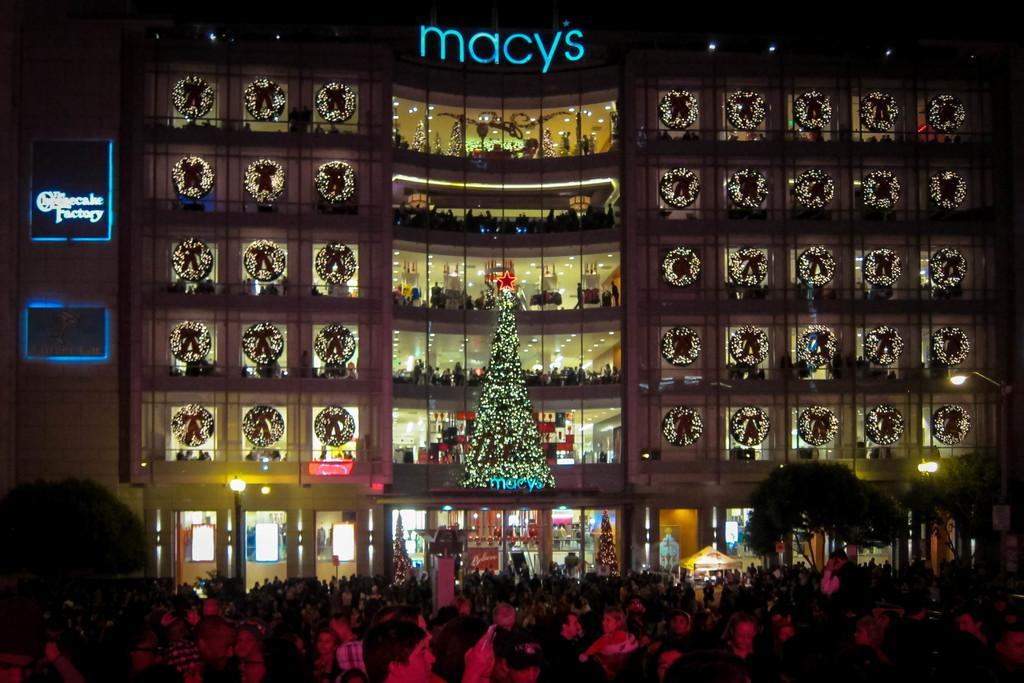In one or two sentences, can you explain what this image depicts? In the center of the image we can see a building. It is decorated with decors. In the center there is an xmas tree. At the bottom there is crowd and we can see trees. 